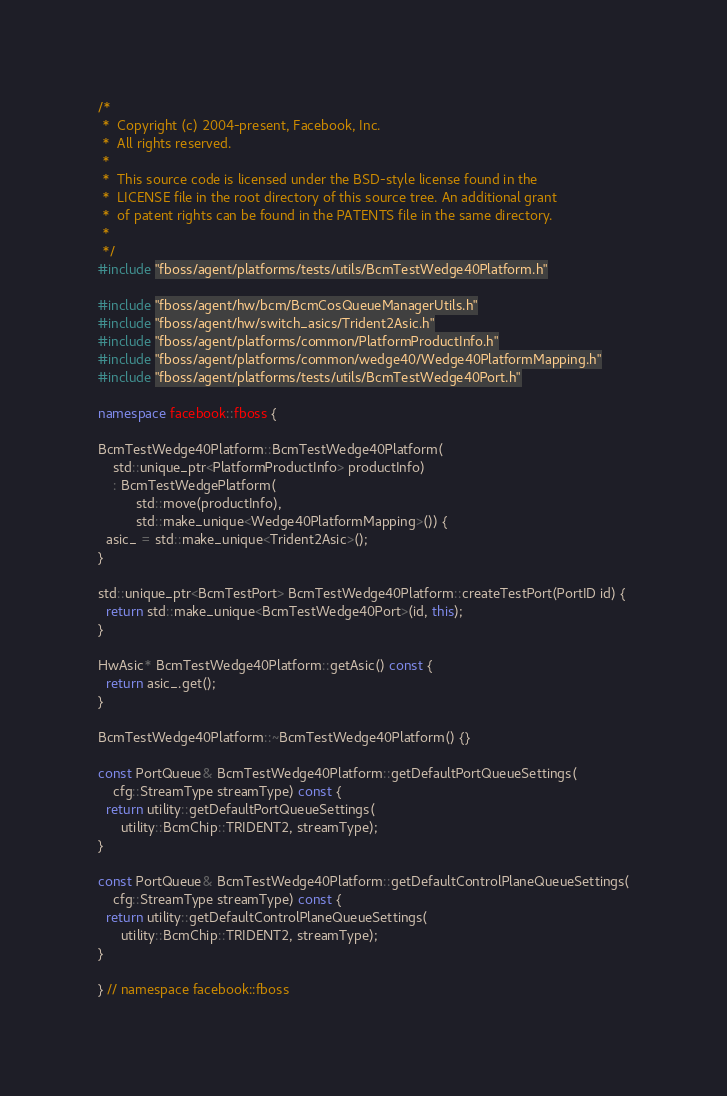<code> <loc_0><loc_0><loc_500><loc_500><_C++_>/*
 *  Copyright (c) 2004-present, Facebook, Inc.
 *  All rights reserved.
 *
 *  This source code is licensed under the BSD-style license found in the
 *  LICENSE file in the root directory of this source tree. An additional grant
 *  of patent rights can be found in the PATENTS file in the same directory.
 *
 */
#include "fboss/agent/platforms/tests/utils/BcmTestWedge40Platform.h"

#include "fboss/agent/hw/bcm/BcmCosQueueManagerUtils.h"
#include "fboss/agent/hw/switch_asics/Trident2Asic.h"
#include "fboss/agent/platforms/common/PlatformProductInfo.h"
#include "fboss/agent/platforms/common/wedge40/Wedge40PlatformMapping.h"
#include "fboss/agent/platforms/tests/utils/BcmTestWedge40Port.h"

namespace facebook::fboss {

BcmTestWedge40Platform::BcmTestWedge40Platform(
    std::unique_ptr<PlatformProductInfo> productInfo)
    : BcmTestWedgePlatform(
          std::move(productInfo),
          std::make_unique<Wedge40PlatformMapping>()) {
  asic_ = std::make_unique<Trident2Asic>();
}

std::unique_ptr<BcmTestPort> BcmTestWedge40Platform::createTestPort(PortID id) {
  return std::make_unique<BcmTestWedge40Port>(id, this);
}

HwAsic* BcmTestWedge40Platform::getAsic() const {
  return asic_.get();
}

BcmTestWedge40Platform::~BcmTestWedge40Platform() {}

const PortQueue& BcmTestWedge40Platform::getDefaultPortQueueSettings(
    cfg::StreamType streamType) const {
  return utility::getDefaultPortQueueSettings(
      utility::BcmChip::TRIDENT2, streamType);
}

const PortQueue& BcmTestWedge40Platform::getDefaultControlPlaneQueueSettings(
    cfg::StreamType streamType) const {
  return utility::getDefaultControlPlaneQueueSettings(
      utility::BcmChip::TRIDENT2, streamType);
}

} // namespace facebook::fboss
</code> 